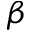<formula> <loc_0><loc_0><loc_500><loc_500>\beta</formula> 